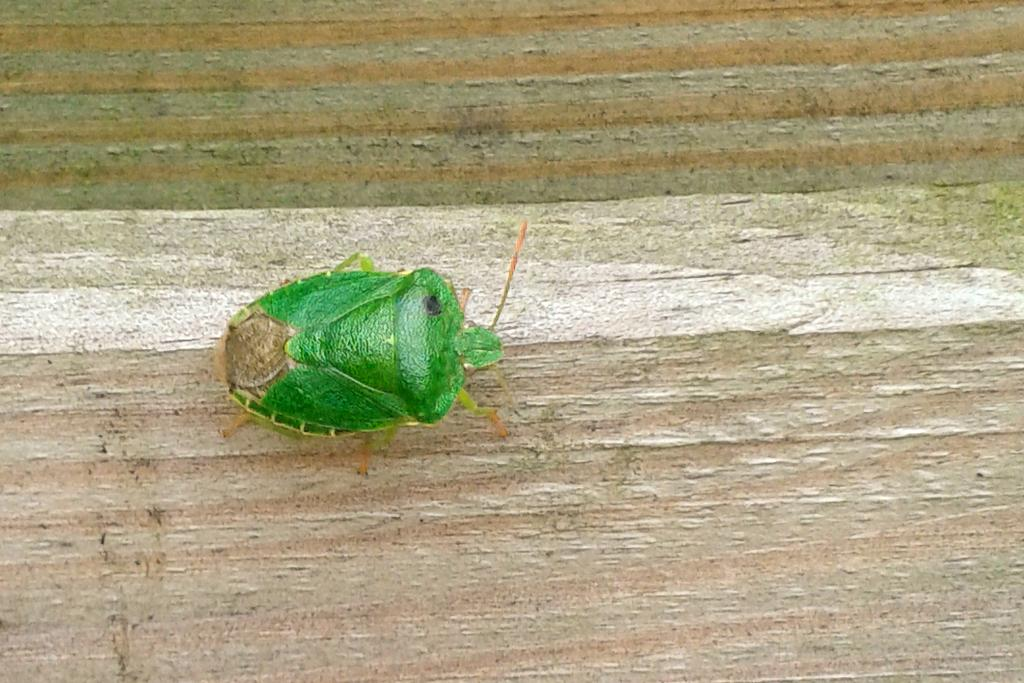What type of creature can be seen in the image? There is an insect in the image. Where is the insect located in the image? The insect is on the floor. What type of skin condition is visible on the insect in the image? There is no indication of a skin condition on the insect in the image, as it is a simple representation of an insect. 